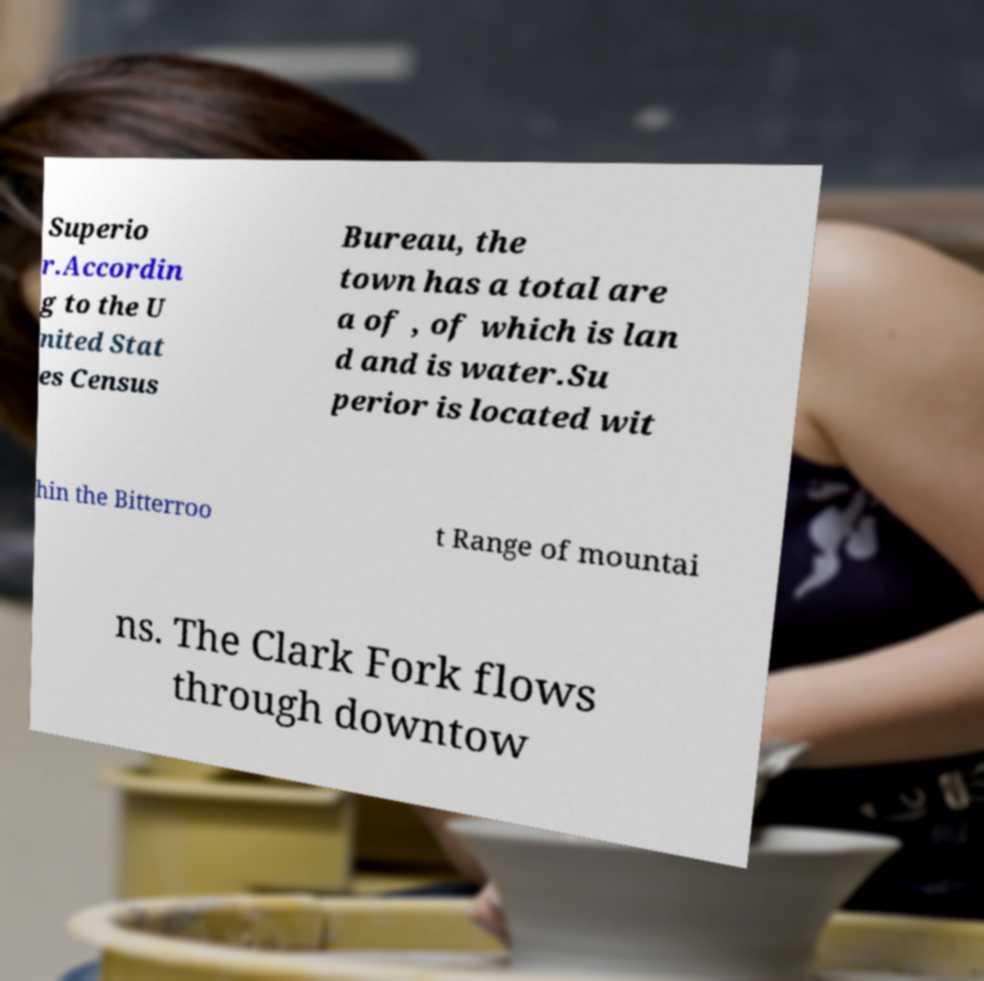There's text embedded in this image that I need extracted. Can you transcribe it verbatim? Superio r.Accordin g to the U nited Stat es Census Bureau, the town has a total are a of , of which is lan d and is water.Su perior is located wit hin the Bitterroo t Range of mountai ns. The Clark Fork flows through downtow 